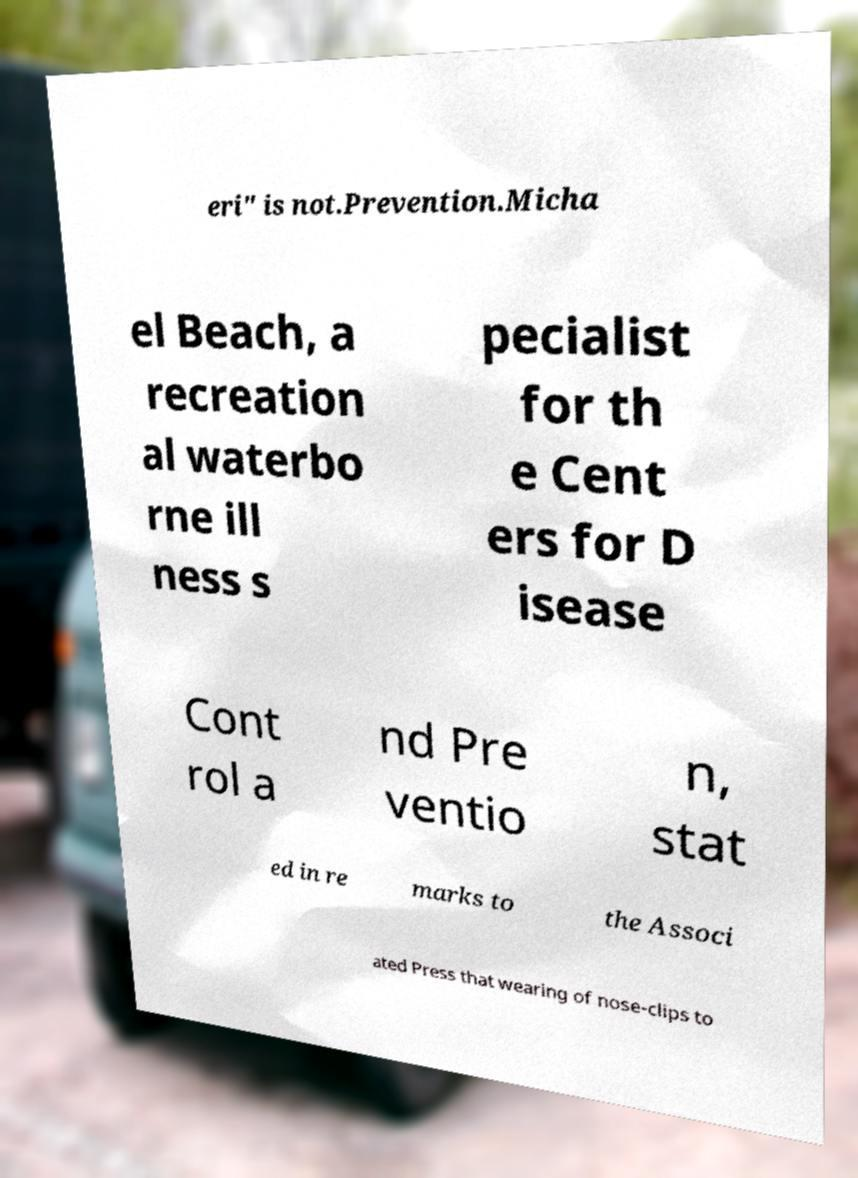There's text embedded in this image that I need extracted. Can you transcribe it verbatim? eri" is not.Prevention.Micha el Beach, a recreation al waterbo rne ill ness s pecialist for th e Cent ers for D isease Cont rol a nd Pre ventio n, stat ed in re marks to the Associ ated Press that wearing of nose-clips to 